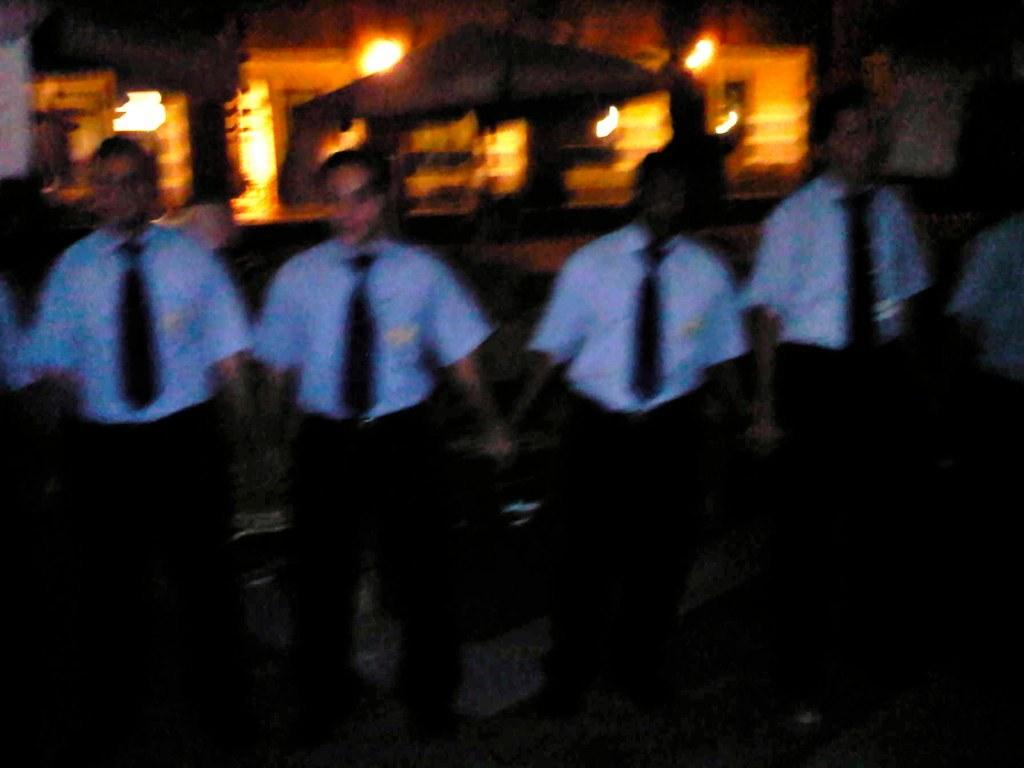How many people are in the image? There is a group of people in the image, but the exact number cannot be determined from the provided facts. What are the people doing in the image? The people are standing on a path in the image. What can be inferred about the lighting conditions in the image? The image is set in a dark environment. What is visible in the background of the image? There are blurred items in the background of the image. Reasoning: Let's think step by following the guidelines to produce the conversation. We start by acknowledging the presence of a group of people in the image, but we avoid specifying the exact number since it is not mentioned in the facts. We then describe the action of the people, which is standing on a path. Next, we address the lighting conditions by mentioning that the image is set in a dark environment. Finally, we discuss the background of the image, noting that there are blurred items. Absurd Question/Answer: How does the pencil help the people navigate the path in the image? There is no pencil present in the image, so it cannot help the people navigate the path. 